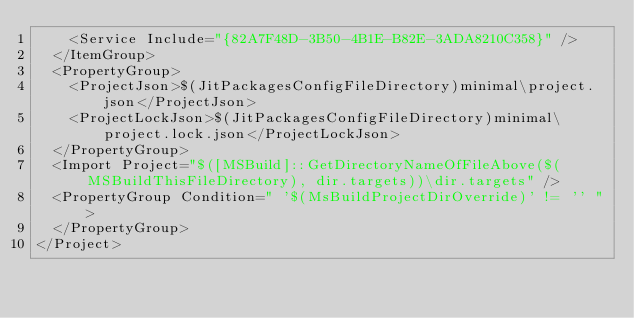<code> <loc_0><loc_0><loc_500><loc_500><_XML_>    <Service Include="{82A7F48D-3B50-4B1E-B82E-3ADA8210C358}" />
  </ItemGroup>
  <PropertyGroup>
    <ProjectJson>$(JitPackagesConfigFileDirectory)minimal\project.json</ProjectJson>
    <ProjectLockJson>$(JitPackagesConfigFileDirectory)minimal\project.lock.json</ProjectLockJson>
  </PropertyGroup>
  <Import Project="$([MSBuild]::GetDirectoryNameOfFileAbove($(MSBuildThisFileDirectory), dir.targets))\dir.targets" />
  <PropertyGroup Condition=" '$(MsBuildProjectDirOverride)' != '' ">
  </PropertyGroup> 
</Project>
</code> 